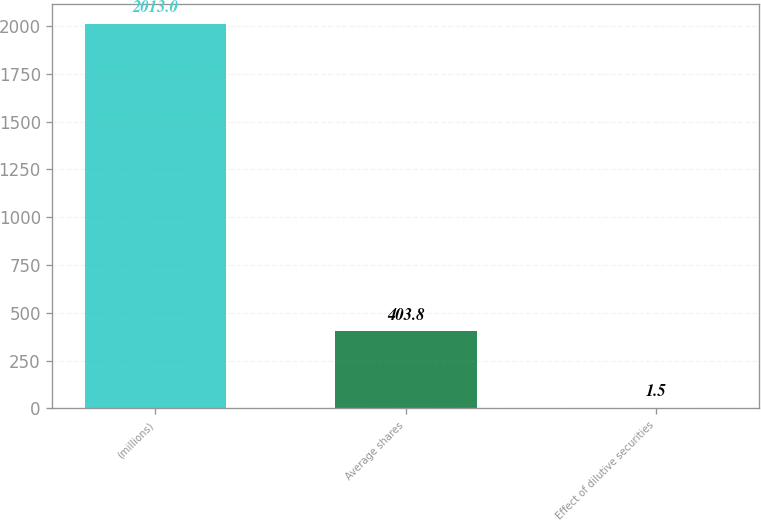Convert chart to OTSL. <chart><loc_0><loc_0><loc_500><loc_500><bar_chart><fcel>(millions)<fcel>Average shares<fcel>Effect of dilutive securities<nl><fcel>2013<fcel>403.8<fcel>1.5<nl></chart> 